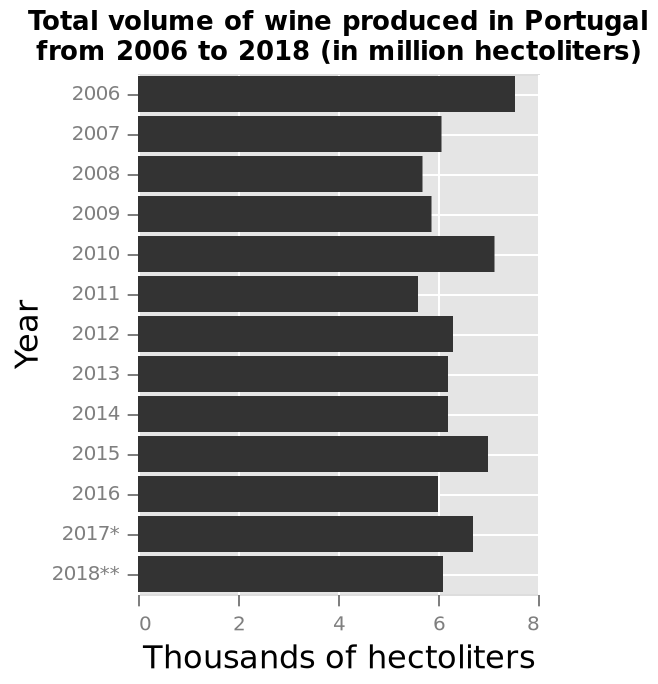<image>
What year had the highest wine production? The highest wine production was in 2006. Was there any significant change in wine production between 2010 and 2015? No, the wine production between 2010 and 2015 was consistent, similar to the other years. 